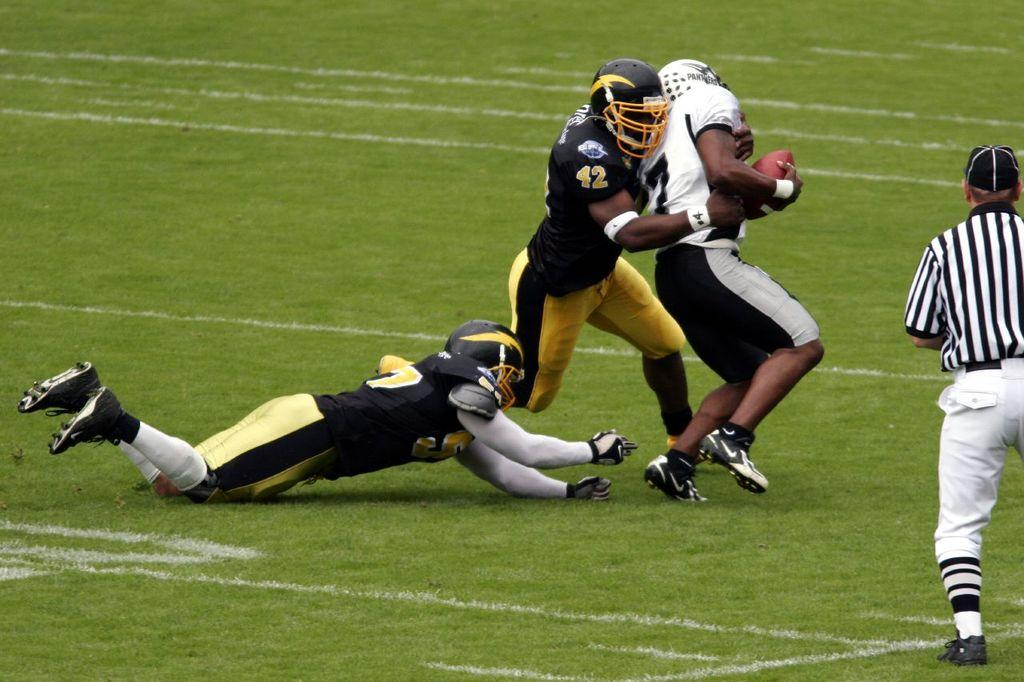How many people are present in the image? There are four people on the ground in the image. What is one person holding in the image? One person is holding a ball. What type of surface is visible in the background of the image? There is grass visible in the background of the image. Is there an umbrella being used by any of the people in the image? No, there is no umbrella present in the image. Can you describe how high the roof is in the image? There is no roof present in the image; it is an outdoor scene with grass in the background. 